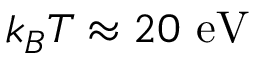Convert formula to latex. <formula><loc_0><loc_0><loc_500><loc_500>k _ { B } T \approx 2 0 \ e V</formula> 